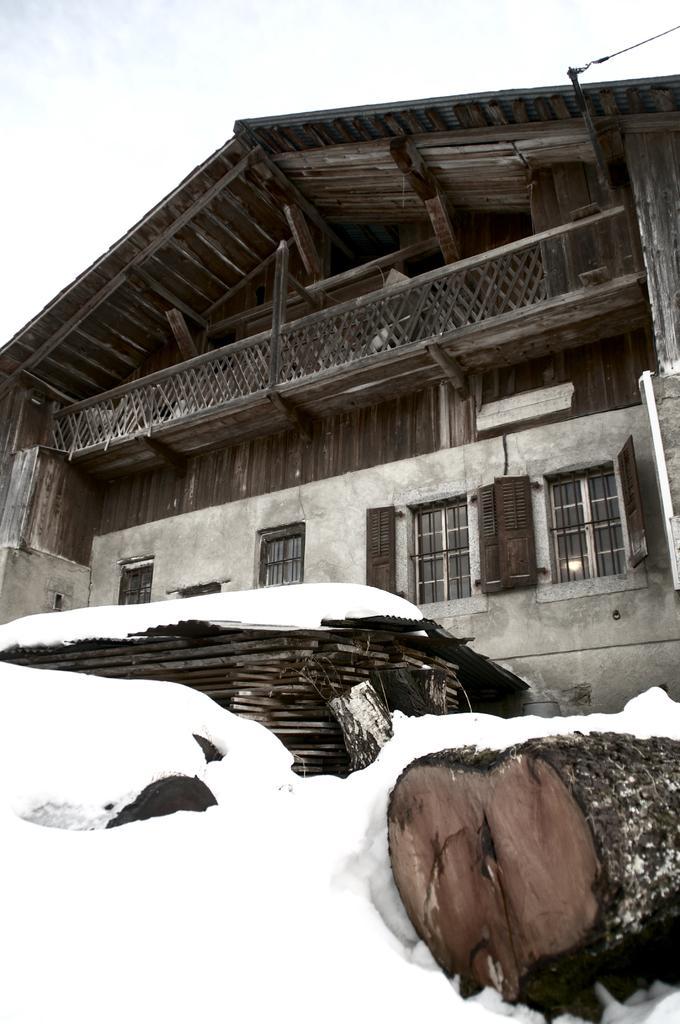Please provide a concise description of this image. In this picture I can see a house , in front of house I can see wooden object ,at the top I can see the sky 